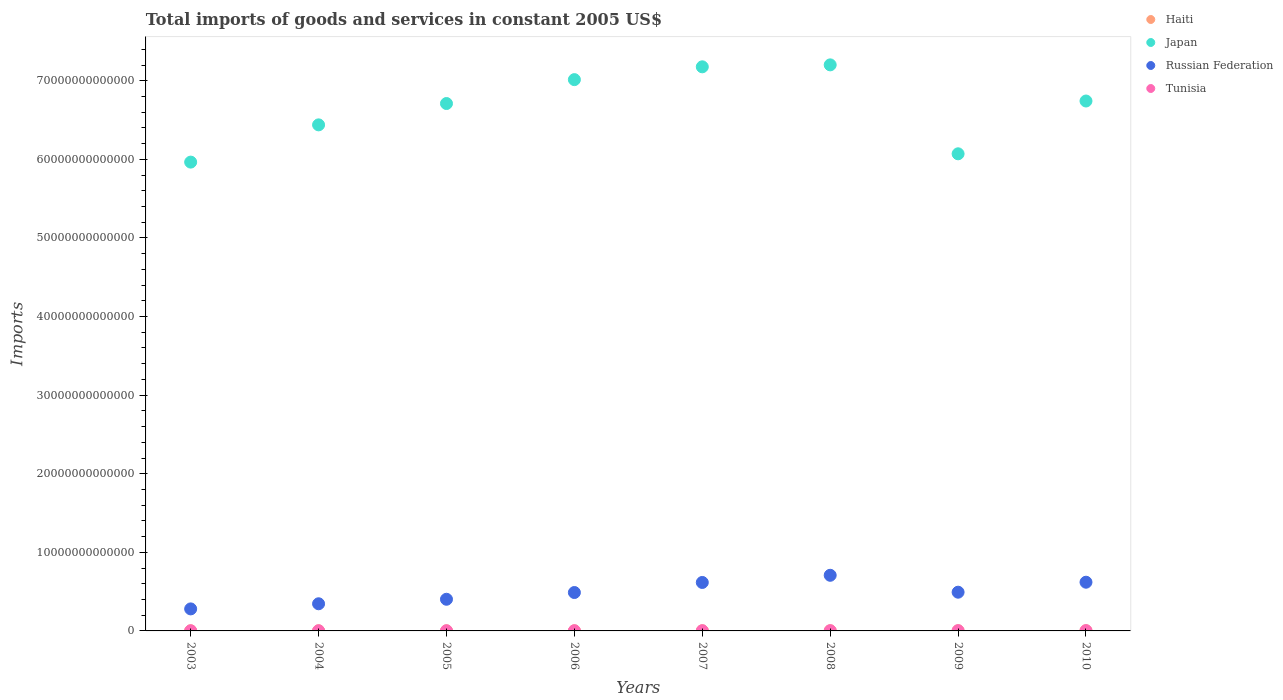How many different coloured dotlines are there?
Offer a very short reply. 4. What is the total imports of goods and services in Japan in 2008?
Offer a very short reply. 7.20e+13. Across all years, what is the maximum total imports of goods and services in Japan?
Ensure brevity in your answer.  7.20e+13. Across all years, what is the minimum total imports of goods and services in Haiti?
Offer a very short reply. 1.51e+1. What is the total total imports of goods and services in Russian Federation in the graph?
Your response must be concise. 3.95e+13. What is the difference between the total imports of goods and services in Russian Federation in 2003 and that in 2007?
Provide a succinct answer. -3.36e+12. What is the difference between the total imports of goods and services in Haiti in 2009 and the total imports of goods and services in Japan in 2008?
Offer a terse response. -7.20e+13. What is the average total imports of goods and services in Tunisia per year?
Make the answer very short. 2.48e+1. In the year 2009, what is the difference between the total imports of goods and services in Haiti and total imports of goods and services in Japan?
Give a very brief answer. -6.07e+13. What is the ratio of the total imports of goods and services in Japan in 2006 to that in 2007?
Your answer should be very brief. 0.98. Is the total imports of goods and services in Japan in 2005 less than that in 2007?
Your response must be concise. Yes. Is the difference between the total imports of goods and services in Haiti in 2003 and 2004 greater than the difference between the total imports of goods and services in Japan in 2003 and 2004?
Ensure brevity in your answer.  Yes. What is the difference between the highest and the second highest total imports of goods and services in Japan?
Make the answer very short. 2.48e+11. What is the difference between the highest and the lowest total imports of goods and services in Tunisia?
Keep it short and to the point. 1.69e+1. In how many years, is the total imports of goods and services in Russian Federation greater than the average total imports of goods and services in Russian Federation taken over all years?
Give a very brief answer. 3. Is it the case that in every year, the sum of the total imports of goods and services in Haiti and total imports of goods and services in Japan  is greater than the sum of total imports of goods and services in Russian Federation and total imports of goods and services in Tunisia?
Ensure brevity in your answer.  No. Is the total imports of goods and services in Tunisia strictly less than the total imports of goods and services in Haiti over the years?
Make the answer very short. No. How many dotlines are there?
Offer a terse response. 4. How many years are there in the graph?
Keep it short and to the point. 8. What is the difference between two consecutive major ticks on the Y-axis?
Give a very brief answer. 1.00e+13. Are the values on the major ticks of Y-axis written in scientific E-notation?
Ensure brevity in your answer.  No. Does the graph contain grids?
Provide a succinct answer. No. What is the title of the graph?
Give a very brief answer. Total imports of goods and services in constant 2005 US$. What is the label or title of the Y-axis?
Offer a very short reply. Imports. What is the Imports in Haiti in 2003?
Ensure brevity in your answer.  1.52e+1. What is the Imports of Japan in 2003?
Make the answer very short. 5.96e+13. What is the Imports in Russian Federation in 2003?
Provide a succinct answer. 2.80e+12. What is the Imports in Tunisia in 2003?
Your answer should be compact. 1.80e+1. What is the Imports of Haiti in 2004?
Offer a terse response. 1.51e+1. What is the Imports in Japan in 2004?
Your answer should be very brief. 6.44e+13. What is the Imports of Russian Federation in 2004?
Give a very brief answer. 3.45e+12. What is the Imports of Tunisia in 2004?
Offer a very short reply. 1.85e+1. What is the Imports in Haiti in 2005?
Your response must be concise. 1.61e+1. What is the Imports in Japan in 2005?
Give a very brief answer. 6.71e+13. What is the Imports of Russian Federation in 2005?
Your answer should be compact. 4.03e+12. What is the Imports in Tunisia in 2005?
Your answer should be compact. 1.84e+1. What is the Imports in Haiti in 2006?
Your response must be concise. 1.64e+1. What is the Imports of Japan in 2006?
Your answer should be compact. 7.01e+13. What is the Imports in Russian Federation in 2006?
Ensure brevity in your answer.  4.89e+12. What is the Imports of Tunisia in 2006?
Offer a terse response. 2.17e+1. What is the Imports in Haiti in 2007?
Keep it short and to the point. 1.64e+1. What is the Imports of Japan in 2007?
Keep it short and to the point. 7.18e+13. What is the Imports of Russian Federation in 2007?
Give a very brief answer. 6.17e+12. What is the Imports in Tunisia in 2007?
Offer a very short reply. 2.55e+1. What is the Imports in Haiti in 2008?
Make the answer very short. 1.73e+1. What is the Imports in Japan in 2008?
Make the answer very short. 7.20e+13. What is the Imports in Russian Federation in 2008?
Offer a very short reply. 7.08e+12. What is the Imports of Tunisia in 2008?
Offer a very short reply. 2.96e+1. What is the Imports of Haiti in 2009?
Make the answer very short. 1.83e+1. What is the Imports in Japan in 2009?
Your answer should be compact. 6.07e+13. What is the Imports in Russian Federation in 2009?
Your answer should be compact. 4.93e+12. What is the Imports in Tunisia in 2009?
Your response must be concise. 3.16e+1. What is the Imports in Haiti in 2010?
Your answer should be very brief. 2.21e+1. What is the Imports of Japan in 2010?
Your response must be concise. 6.74e+13. What is the Imports of Russian Federation in 2010?
Offer a very short reply. 6.20e+12. What is the Imports of Tunisia in 2010?
Make the answer very short. 3.49e+1. Across all years, what is the maximum Imports of Haiti?
Make the answer very short. 2.21e+1. Across all years, what is the maximum Imports of Japan?
Make the answer very short. 7.20e+13. Across all years, what is the maximum Imports of Russian Federation?
Your answer should be compact. 7.08e+12. Across all years, what is the maximum Imports in Tunisia?
Make the answer very short. 3.49e+1. Across all years, what is the minimum Imports in Haiti?
Give a very brief answer. 1.51e+1. Across all years, what is the minimum Imports in Japan?
Your answer should be very brief. 5.96e+13. Across all years, what is the minimum Imports of Russian Federation?
Your answer should be compact. 2.80e+12. Across all years, what is the minimum Imports of Tunisia?
Provide a succinct answer. 1.80e+1. What is the total Imports in Haiti in the graph?
Keep it short and to the point. 1.37e+11. What is the total Imports in Japan in the graph?
Offer a very short reply. 5.33e+14. What is the total Imports in Russian Federation in the graph?
Provide a short and direct response. 3.95e+13. What is the total Imports in Tunisia in the graph?
Ensure brevity in your answer.  1.98e+11. What is the difference between the Imports of Haiti in 2003 and that in 2004?
Keep it short and to the point. 1.62e+08. What is the difference between the Imports of Japan in 2003 and that in 2004?
Provide a short and direct response. -4.74e+12. What is the difference between the Imports in Russian Federation in 2003 and that in 2004?
Offer a very short reply. -6.53e+11. What is the difference between the Imports in Tunisia in 2003 and that in 2004?
Provide a short and direct response. -4.89e+08. What is the difference between the Imports of Haiti in 2003 and that in 2005?
Your response must be concise. -8.37e+08. What is the difference between the Imports in Japan in 2003 and that in 2005?
Keep it short and to the point. -7.45e+12. What is the difference between the Imports in Russian Federation in 2003 and that in 2005?
Your answer should be very brief. -1.23e+12. What is the difference between the Imports in Tunisia in 2003 and that in 2005?
Keep it short and to the point. -4.81e+08. What is the difference between the Imports in Haiti in 2003 and that in 2006?
Make the answer very short. -1.14e+09. What is the difference between the Imports in Japan in 2003 and that in 2006?
Your answer should be compact. -1.05e+13. What is the difference between the Imports of Russian Federation in 2003 and that in 2006?
Provide a short and direct response. -2.08e+12. What is the difference between the Imports in Tunisia in 2003 and that in 2006?
Your answer should be very brief. -3.72e+09. What is the difference between the Imports in Haiti in 2003 and that in 2007?
Give a very brief answer. -1.22e+09. What is the difference between the Imports in Japan in 2003 and that in 2007?
Offer a terse response. -1.21e+13. What is the difference between the Imports of Russian Federation in 2003 and that in 2007?
Your answer should be compact. -3.36e+12. What is the difference between the Imports in Tunisia in 2003 and that in 2007?
Ensure brevity in your answer.  -7.56e+09. What is the difference between the Imports in Haiti in 2003 and that in 2008?
Offer a terse response. -2.08e+09. What is the difference between the Imports in Japan in 2003 and that in 2008?
Offer a terse response. -1.24e+13. What is the difference between the Imports in Russian Federation in 2003 and that in 2008?
Provide a succinct answer. -4.28e+12. What is the difference between the Imports of Tunisia in 2003 and that in 2008?
Provide a succinct answer. -1.16e+1. What is the difference between the Imports of Haiti in 2003 and that in 2009?
Provide a succinct answer. -3.09e+09. What is the difference between the Imports of Japan in 2003 and that in 2009?
Ensure brevity in your answer.  -1.06e+12. What is the difference between the Imports of Russian Federation in 2003 and that in 2009?
Your answer should be very brief. -2.12e+12. What is the difference between the Imports of Tunisia in 2003 and that in 2009?
Your answer should be compact. -1.37e+1. What is the difference between the Imports in Haiti in 2003 and that in 2010?
Ensure brevity in your answer.  -6.89e+09. What is the difference between the Imports of Japan in 2003 and that in 2010?
Your answer should be very brief. -7.77e+12. What is the difference between the Imports in Russian Federation in 2003 and that in 2010?
Provide a short and direct response. -3.40e+12. What is the difference between the Imports in Tunisia in 2003 and that in 2010?
Offer a very short reply. -1.69e+1. What is the difference between the Imports in Haiti in 2004 and that in 2005?
Offer a terse response. -9.99e+08. What is the difference between the Imports of Japan in 2004 and that in 2005?
Your answer should be compact. -2.71e+12. What is the difference between the Imports in Russian Federation in 2004 and that in 2005?
Your answer should be compact. -5.73e+11. What is the difference between the Imports in Tunisia in 2004 and that in 2005?
Give a very brief answer. 8.07e+06. What is the difference between the Imports of Haiti in 2004 and that in 2006?
Provide a short and direct response. -1.30e+09. What is the difference between the Imports in Japan in 2004 and that in 2006?
Provide a succinct answer. -5.75e+12. What is the difference between the Imports of Russian Federation in 2004 and that in 2006?
Your response must be concise. -1.43e+12. What is the difference between the Imports in Tunisia in 2004 and that in 2006?
Your answer should be compact. -3.23e+09. What is the difference between the Imports of Haiti in 2004 and that in 2007?
Provide a succinct answer. -1.38e+09. What is the difference between the Imports of Japan in 2004 and that in 2007?
Give a very brief answer. -7.38e+12. What is the difference between the Imports of Russian Federation in 2004 and that in 2007?
Provide a succinct answer. -2.71e+12. What is the difference between the Imports in Tunisia in 2004 and that in 2007?
Your response must be concise. -7.07e+09. What is the difference between the Imports of Haiti in 2004 and that in 2008?
Your answer should be very brief. -2.24e+09. What is the difference between the Imports in Japan in 2004 and that in 2008?
Provide a succinct answer. -7.63e+12. What is the difference between the Imports of Russian Federation in 2004 and that in 2008?
Your answer should be very brief. -3.62e+12. What is the difference between the Imports of Tunisia in 2004 and that in 2008?
Offer a very short reply. -1.11e+1. What is the difference between the Imports of Haiti in 2004 and that in 2009?
Your answer should be compact. -3.26e+09. What is the difference between the Imports in Japan in 2004 and that in 2009?
Offer a terse response. 3.68e+12. What is the difference between the Imports in Russian Federation in 2004 and that in 2009?
Your response must be concise. -1.47e+12. What is the difference between the Imports in Tunisia in 2004 and that in 2009?
Offer a very short reply. -1.32e+1. What is the difference between the Imports of Haiti in 2004 and that in 2010?
Make the answer very short. -7.05e+09. What is the difference between the Imports in Japan in 2004 and that in 2010?
Ensure brevity in your answer.  -3.03e+12. What is the difference between the Imports in Russian Federation in 2004 and that in 2010?
Your response must be concise. -2.74e+12. What is the difference between the Imports of Tunisia in 2004 and that in 2010?
Give a very brief answer. -1.64e+1. What is the difference between the Imports in Haiti in 2005 and that in 2006?
Keep it short and to the point. -3.03e+08. What is the difference between the Imports of Japan in 2005 and that in 2006?
Provide a succinct answer. -3.04e+12. What is the difference between the Imports of Russian Federation in 2005 and that in 2006?
Offer a very short reply. -8.58e+11. What is the difference between the Imports in Tunisia in 2005 and that in 2006?
Your answer should be very brief. -3.24e+09. What is the difference between the Imports in Haiti in 2005 and that in 2007?
Your answer should be very brief. -3.78e+08. What is the difference between the Imports of Japan in 2005 and that in 2007?
Give a very brief answer. -4.67e+12. What is the difference between the Imports in Russian Federation in 2005 and that in 2007?
Make the answer very short. -2.14e+12. What is the difference between the Imports of Tunisia in 2005 and that in 2007?
Give a very brief answer. -7.08e+09. What is the difference between the Imports of Haiti in 2005 and that in 2008?
Offer a terse response. -1.24e+09. What is the difference between the Imports in Japan in 2005 and that in 2008?
Offer a very short reply. -4.92e+12. What is the difference between the Imports of Russian Federation in 2005 and that in 2008?
Your answer should be very brief. -3.05e+12. What is the difference between the Imports in Tunisia in 2005 and that in 2008?
Offer a terse response. -1.11e+1. What is the difference between the Imports in Haiti in 2005 and that in 2009?
Your response must be concise. -2.26e+09. What is the difference between the Imports of Japan in 2005 and that in 2009?
Ensure brevity in your answer.  6.40e+12. What is the difference between the Imports in Russian Federation in 2005 and that in 2009?
Provide a short and direct response. -8.99e+11. What is the difference between the Imports of Tunisia in 2005 and that in 2009?
Your answer should be compact. -1.32e+1. What is the difference between the Imports of Haiti in 2005 and that in 2010?
Provide a short and direct response. -6.06e+09. What is the difference between the Imports of Japan in 2005 and that in 2010?
Offer a very short reply. -3.20e+11. What is the difference between the Imports of Russian Federation in 2005 and that in 2010?
Give a very brief answer. -2.17e+12. What is the difference between the Imports of Tunisia in 2005 and that in 2010?
Keep it short and to the point. -1.64e+1. What is the difference between the Imports of Haiti in 2006 and that in 2007?
Give a very brief answer. -7.50e+07. What is the difference between the Imports in Japan in 2006 and that in 2007?
Provide a succinct answer. -1.63e+12. What is the difference between the Imports of Russian Federation in 2006 and that in 2007?
Your response must be concise. -1.28e+12. What is the difference between the Imports of Tunisia in 2006 and that in 2007?
Your response must be concise. -3.83e+09. What is the difference between the Imports of Haiti in 2006 and that in 2008?
Provide a succinct answer. -9.42e+08. What is the difference between the Imports of Japan in 2006 and that in 2008?
Offer a terse response. -1.88e+12. What is the difference between the Imports in Russian Federation in 2006 and that in 2008?
Your answer should be very brief. -2.19e+12. What is the difference between the Imports of Tunisia in 2006 and that in 2008?
Your answer should be very brief. -7.89e+09. What is the difference between the Imports of Haiti in 2006 and that in 2009?
Your answer should be very brief. -1.95e+09. What is the difference between the Imports of Japan in 2006 and that in 2009?
Your response must be concise. 9.44e+12. What is the difference between the Imports in Russian Federation in 2006 and that in 2009?
Ensure brevity in your answer.  -4.08e+1. What is the difference between the Imports in Tunisia in 2006 and that in 2009?
Your response must be concise. -9.94e+09. What is the difference between the Imports of Haiti in 2006 and that in 2010?
Your response must be concise. -5.75e+09. What is the difference between the Imports in Japan in 2006 and that in 2010?
Provide a succinct answer. 2.72e+12. What is the difference between the Imports in Russian Federation in 2006 and that in 2010?
Your answer should be very brief. -1.31e+12. What is the difference between the Imports in Tunisia in 2006 and that in 2010?
Provide a succinct answer. -1.32e+1. What is the difference between the Imports in Haiti in 2007 and that in 2008?
Offer a terse response. -8.67e+08. What is the difference between the Imports in Japan in 2007 and that in 2008?
Give a very brief answer. -2.48e+11. What is the difference between the Imports of Russian Federation in 2007 and that in 2008?
Give a very brief answer. -9.13e+11. What is the difference between the Imports in Tunisia in 2007 and that in 2008?
Provide a short and direct response. -4.06e+09. What is the difference between the Imports in Haiti in 2007 and that in 2009?
Provide a short and direct response. -1.88e+09. What is the difference between the Imports of Japan in 2007 and that in 2009?
Make the answer very short. 1.11e+13. What is the difference between the Imports of Russian Federation in 2007 and that in 2009?
Your response must be concise. 1.24e+12. What is the difference between the Imports in Tunisia in 2007 and that in 2009?
Provide a succinct answer. -6.11e+09. What is the difference between the Imports of Haiti in 2007 and that in 2010?
Give a very brief answer. -5.68e+09. What is the difference between the Imports in Japan in 2007 and that in 2010?
Your answer should be very brief. 4.35e+12. What is the difference between the Imports in Russian Federation in 2007 and that in 2010?
Your response must be concise. -3.18e+1. What is the difference between the Imports of Tunisia in 2007 and that in 2010?
Offer a terse response. -9.34e+09. What is the difference between the Imports in Haiti in 2008 and that in 2009?
Ensure brevity in your answer.  -1.01e+09. What is the difference between the Imports of Japan in 2008 and that in 2009?
Give a very brief answer. 1.13e+13. What is the difference between the Imports of Russian Federation in 2008 and that in 2009?
Your response must be concise. 2.15e+12. What is the difference between the Imports in Tunisia in 2008 and that in 2009?
Your response must be concise. -2.05e+09. What is the difference between the Imports of Haiti in 2008 and that in 2010?
Ensure brevity in your answer.  -4.81e+09. What is the difference between the Imports of Japan in 2008 and that in 2010?
Your answer should be compact. 4.60e+12. What is the difference between the Imports in Russian Federation in 2008 and that in 2010?
Your answer should be very brief. 8.81e+11. What is the difference between the Imports of Tunisia in 2008 and that in 2010?
Your answer should be compact. -5.28e+09. What is the difference between the Imports in Haiti in 2009 and that in 2010?
Provide a short and direct response. -3.80e+09. What is the difference between the Imports in Japan in 2009 and that in 2010?
Provide a short and direct response. -6.72e+12. What is the difference between the Imports of Russian Federation in 2009 and that in 2010?
Make the answer very short. -1.27e+12. What is the difference between the Imports in Tunisia in 2009 and that in 2010?
Offer a terse response. -3.23e+09. What is the difference between the Imports of Haiti in 2003 and the Imports of Japan in 2004?
Give a very brief answer. -6.44e+13. What is the difference between the Imports of Haiti in 2003 and the Imports of Russian Federation in 2004?
Give a very brief answer. -3.44e+12. What is the difference between the Imports of Haiti in 2003 and the Imports of Tunisia in 2004?
Provide a succinct answer. -3.23e+09. What is the difference between the Imports in Japan in 2003 and the Imports in Russian Federation in 2004?
Your response must be concise. 5.62e+13. What is the difference between the Imports of Japan in 2003 and the Imports of Tunisia in 2004?
Your answer should be compact. 5.96e+13. What is the difference between the Imports in Russian Federation in 2003 and the Imports in Tunisia in 2004?
Keep it short and to the point. 2.78e+12. What is the difference between the Imports of Haiti in 2003 and the Imports of Japan in 2005?
Your response must be concise. -6.71e+13. What is the difference between the Imports in Haiti in 2003 and the Imports in Russian Federation in 2005?
Your response must be concise. -4.01e+12. What is the difference between the Imports in Haiti in 2003 and the Imports in Tunisia in 2005?
Ensure brevity in your answer.  -3.22e+09. What is the difference between the Imports of Japan in 2003 and the Imports of Russian Federation in 2005?
Provide a succinct answer. 5.56e+13. What is the difference between the Imports of Japan in 2003 and the Imports of Tunisia in 2005?
Your answer should be very brief. 5.96e+13. What is the difference between the Imports in Russian Federation in 2003 and the Imports in Tunisia in 2005?
Provide a short and direct response. 2.78e+12. What is the difference between the Imports of Haiti in 2003 and the Imports of Japan in 2006?
Your response must be concise. -7.01e+13. What is the difference between the Imports in Haiti in 2003 and the Imports in Russian Federation in 2006?
Your answer should be compact. -4.87e+12. What is the difference between the Imports in Haiti in 2003 and the Imports in Tunisia in 2006?
Your response must be concise. -6.46e+09. What is the difference between the Imports in Japan in 2003 and the Imports in Russian Federation in 2006?
Offer a very short reply. 5.48e+13. What is the difference between the Imports of Japan in 2003 and the Imports of Tunisia in 2006?
Provide a succinct answer. 5.96e+13. What is the difference between the Imports of Russian Federation in 2003 and the Imports of Tunisia in 2006?
Provide a succinct answer. 2.78e+12. What is the difference between the Imports in Haiti in 2003 and the Imports in Japan in 2007?
Give a very brief answer. -7.18e+13. What is the difference between the Imports in Haiti in 2003 and the Imports in Russian Federation in 2007?
Your answer should be very brief. -6.15e+12. What is the difference between the Imports in Haiti in 2003 and the Imports in Tunisia in 2007?
Make the answer very short. -1.03e+1. What is the difference between the Imports in Japan in 2003 and the Imports in Russian Federation in 2007?
Your answer should be compact. 5.35e+13. What is the difference between the Imports of Japan in 2003 and the Imports of Tunisia in 2007?
Your answer should be compact. 5.96e+13. What is the difference between the Imports in Russian Federation in 2003 and the Imports in Tunisia in 2007?
Provide a succinct answer. 2.78e+12. What is the difference between the Imports of Haiti in 2003 and the Imports of Japan in 2008?
Keep it short and to the point. -7.20e+13. What is the difference between the Imports of Haiti in 2003 and the Imports of Russian Federation in 2008?
Offer a very short reply. -7.06e+12. What is the difference between the Imports of Haiti in 2003 and the Imports of Tunisia in 2008?
Provide a short and direct response. -1.43e+1. What is the difference between the Imports in Japan in 2003 and the Imports in Russian Federation in 2008?
Offer a very short reply. 5.26e+13. What is the difference between the Imports in Japan in 2003 and the Imports in Tunisia in 2008?
Provide a short and direct response. 5.96e+13. What is the difference between the Imports of Russian Federation in 2003 and the Imports of Tunisia in 2008?
Offer a very short reply. 2.77e+12. What is the difference between the Imports of Haiti in 2003 and the Imports of Japan in 2009?
Make the answer very short. -6.07e+13. What is the difference between the Imports of Haiti in 2003 and the Imports of Russian Federation in 2009?
Your response must be concise. -4.91e+12. What is the difference between the Imports of Haiti in 2003 and the Imports of Tunisia in 2009?
Keep it short and to the point. -1.64e+1. What is the difference between the Imports in Japan in 2003 and the Imports in Russian Federation in 2009?
Your response must be concise. 5.47e+13. What is the difference between the Imports of Japan in 2003 and the Imports of Tunisia in 2009?
Offer a terse response. 5.96e+13. What is the difference between the Imports of Russian Federation in 2003 and the Imports of Tunisia in 2009?
Your answer should be compact. 2.77e+12. What is the difference between the Imports in Haiti in 2003 and the Imports in Japan in 2010?
Provide a succinct answer. -6.74e+13. What is the difference between the Imports in Haiti in 2003 and the Imports in Russian Federation in 2010?
Your answer should be very brief. -6.18e+12. What is the difference between the Imports in Haiti in 2003 and the Imports in Tunisia in 2010?
Your response must be concise. -1.96e+1. What is the difference between the Imports of Japan in 2003 and the Imports of Russian Federation in 2010?
Offer a very short reply. 5.34e+13. What is the difference between the Imports in Japan in 2003 and the Imports in Tunisia in 2010?
Provide a succinct answer. 5.96e+13. What is the difference between the Imports in Russian Federation in 2003 and the Imports in Tunisia in 2010?
Offer a very short reply. 2.77e+12. What is the difference between the Imports of Haiti in 2004 and the Imports of Japan in 2005?
Your answer should be very brief. -6.71e+13. What is the difference between the Imports of Haiti in 2004 and the Imports of Russian Federation in 2005?
Make the answer very short. -4.01e+12. What is the difference between the Imports in Haiti in 2004 and the Imports in Tunisia in 2005?
Your response must be concise. -3.38e+09. What is the difference between the Imports of Japan in 2004 and the Imports of Russian Federation in 2005?
Offer a terse response. 6.04e+13. What is the difference between the Imports in Japan in 2004 and the Imports in Tunisia in 2005?
Offer a very short reply. 6.44e+13. What is the difference between the Imports in Russian Federation in 2004 and the Imports in Tunisia in 2005?
Your response must be concise. 3.44e+12. What is the difference between the Imports of Haiti in 2004 and the Imports of Japan in 2006?
Provide a short and direct response. -7.01e+13. What is the difference between the Imports of Haiti in 2004 and the Imports of Russian Federation in 2006?
Make the answer very short. -4.87e+12. What is the difference between the Imports of Haiti in 2004 and the Imports of Tunisia in 2006?
Your response must be concise. -6.62e+09. What is the difference between the Imports in Japan in 2004 and the Imports in Russian Federation in 2006?
Ensure brevity in your answer.  5.95e+13. What is the difference between the Imports of Japan in 2004 and the Imports of Tunisia in 2006?
Make the answer very short. 6.44e+13. What is the difference between the Imports of Russian Federation in 2004 and the Imports of Tunisia in 2006?
Offer a very short reply. 3.43e+12. What is the difference between the Imports in Haiti in 2004 and the Imports in Japan in 2007?
Provide a short and direct response. -7.18e+13. What is the difference between the Imports of Haiti in 2004 and the Imports of Russian Federation in 2007?
Give a very brief answer. -6.15e+12. What is the difference between the Imports of Haiti in 2004 and the Imports of Tunisia in 2007?
Your answer should be very brief. -1.05e+1. What is the difference between the Imports in Japan in 2004 and the Imports in Russian Federation in 2007?
Make the answer very short. 5.82e+13. What is the difference between the Imports in Japan in 2004 and the Imports in Tunisia in 2007?
Offer a very short reply. 6.44e+13. What is the difference between the Imports in Russian Federation in 2004 and the Imports in Tunisia in 2007?
Your answer should be compact. 3.43e+12. What is the difference between the Imports in Haiti in 2004 and the Imports in Japan in 2008?
Your answer should be very brief. -7.20e+13. What is the difference between the Imports of Haiti in 2004 and the Imports of Russian Federation in 2008?
Give a very brief answer. -7.06e+12. What is the difference between the Imports in Haiti in 2004 and the Imports in Tunisia in 2008?
Make the answer very short. -1.45e+1. What is the difference between the Imports in Japan in 2004 and the Imports in Russian Federation in 2008?
Provide a short and direct response. 5.73e+13. What is the difference between the Imports of Japan in 2004 and the Imports of Tunisia in 2008?
Your answer should be very brief. 6.44e+13. What is the difference between the Imports in Russian Federation in 2004 and the Imports in Tunisia in 2008?
Your answer should be compact. 3.42e+12. What is the difference between the Imports of Haiti in 2004 and the Imports of Japan in 2009?
Your answer should be very brief. -6.07e+13. What is the difference between the Imports in Haiti in 2004 and the Imports in Russian Federation in 2009?
Offer a very short reply. -4.91e+12. What is the difference between the Imports of Haiti in 2004 and the Imports of Tunisia in 2009?
Your response must be concise. -1.66e+1. What is the difference between the Imports in Japan in 2004 and the Imports in Russian Federation in 2009?
Offer a very short reply. 5.95e+13. What is the difference between the Imports in Japan in 2004 and the Imports in Tunisia in 2009?
Keep it short and to the point. 6.44e+13. What is the difference between the Imports in Russian Federation in 2004 and the Imports in Tunisia in 2009?
Provide a short and direct response. 3.42e+12. What is the difference between the Imports in Haiti in 2004 and the Imports in Japan in 2010?
Offer a very short reply. -6.74e+13. What is the difference between the Imports of Haiti in 2004 and the Imports of Russian Federation in 2010?
Keep it short and to the point. -6.18e+12. What is the difference between the Imports of Haiti in 2004 and the Imports of Tunisia in 2010?
Ensure brevity in your answer.  -1.98e+1. What is the difference between the Imports of Japan in 2004 and the Imports of Russian Federation in 2010?
Ensure brevity in your answer.  5.82e+13. What is the difference between the Imports in Japan in 2004 and the Imports in Tunisia in 2010?
Ensure brevity in your answer.  6.44e+13. What is the difference between the Imports in Russian Federation in 2004 and the Imports in Tunisia in 2010?
Your answer should be very brief. 3.42e+12. What is the difference between the Imports of Haiti in 2005 and the Imports of Japan in 2006?
Give a very brief answer. -7.01e+13. What is the difference between the Imports in Haiti in 2005 and the Imports in Russian Federation in 2006?
Keep it short and to the point. -4.87e+12. What is the difference between the Imports in Haiti in 2005 and the Imports in Tunisia in 2006?
Give a very brief answer. -5.62e+09. What is the difference between the Imports in Japan in 2005 and the Imports in Russian Federation in 2006?
Your answer should be very brief. 6.22e+13. What is the difference between the Imports in Japan in 2005 and the Imports in Tunisia in 2006?
Offer a terse response. 6.71e+13. What is the difference between the Imports in Russian Federation in 2005 and the Imports in Tunisia in 2006?
Ensure brevity in your answer.  4.01e+12. What is the difference between the Imports of Haiti in 2005 and the Imports of Japan in 2007?
Ensure brevity in your answer.  -7.18e+13. What is the difference between the Imports in Haiti in 2005 and the Imports in Russian Federation in 2007?
Your answer should be very brief. -6.15e+12. What is the difference between the Imports in Haiti in 2005 and the Imports in Tunisia in 2007?
Your response must be concise. -9.46e+09. What is the difference between the Imports in Japan in 2005 and the Imports in Russian Federation in 2007?
Provide a succinct answer. 6.09e+13. What is the difference between the Imports of Japan in 2005 and the Imports of Tunisia in 2007?
Your answer should be very brief. 6.71e+13. What is the difference between the Imports of Russian Federation in 2005 and the Imports of Tunisia in 2007?
Your answer should be very brief. 4.00e+12. What is the difference between the Imports in Haiti in 2005 and the Imports in Japan in 2008?
Give a very brief answer. -7.20e+13. What is the difference between the Imports in Haiti in 2005 and the Imports in Russian Federation in 2008?
Keep it short and to the point. -7.06e+12. What is the difference between the Imports in Haiti in 2005 and the Imports in Tunisia in 2008?
Offer a very short reply. -1.35e+1. What is the difference between the Imports in Japan in 2005 and the Imports in Russian Federation in 2008?
Your answer should be compact. 6.00e+13. What is the difference between the Imports of Japan in 2005 and the Imports of Tunisia in 2008?
Your answer should be compact. 6.71e+13. What is the difference between the Imports of Russian Federation in 2005 and the Imports of Tunisia in 2008?
Your answer should be very brief. 4.00e+12. What is the difference between the Imports in Haiti in 2005 and the Imports in Japan in 2009?
Keep it short and to the point. -6.07e+13. What is the difference between the Imports of Haiti in 2005 and the Imports of Russian Federation in 2009?
Make the answer very short. -4.91e+12. What is the difference between the Imports of Haiti in 2005 and the Imports of Tunisia in 2009?
Give a very brief answer. -1.56e+1. What is the difference between the Imports in Japan in 2005 and the Imports in Russian Federation in 2009?
Offer a very short reply. 6.22e+13. What is the difference between the Imports in Japan in 2005 and the Imports in Tunisia in 2009?
Ensure brevity in your answer.  6.71e+13. What is the difference between the Imports of Russian Federation in 2005 and the Imports of Tunisia in 2009?
Provide a short and direct response. 4.00e+12. What is the difference between the Imports in Haiti in 2005 and the Imports in Japan in 2010?
Your answer should be very brief. -6.74e+13. What is the difference between the Imports in Haiti in 2005 and the Imports in Russian Federation in 2010?
Your answer should be compact. -6.18e+12. What is the difference between the Imports in Haiti in 2005 and the Imports in Tunisia in 2010?
Offer a very short reply. -1.88e+1. What is the difference between the Imports of Japan in 2005 and the Imports of Russian Federation in 2010?
Provide a succinct answer. 6.09e+13. What is the difference between the Imports in Japan in 2005 and the Imports in Tunisia in 2010?
Offer a terse response. 6.71e+13. What is the difference between the Imports of Russian Federation in 2005 and the Imports of Tunisia in 2010?
Ensure brevity in your answer.  3.99e+12. What is the difference between the Imports in Haiti in 2006 and the Imports in Japan in 2007?
Give a very brief answer. -7.18e+13. What is the difference between the Imports of Haiti in 2006 and the Imports of Russian Federation in 2007?
Your answer should be very brief. -6.15e+12. What is the difference between the Imports in Haiti in 2006 and the Imports in Tunisia in 2007?
Keep it short and to the point. -9.15e+09. What is the difference between the Imports of Japan in 2006 and the Imports of Russian Federation in 2007?
Ensure brevity in your answer.  6.40e+13. What is the difference between the Imports of Japan in 2006 and the Imports of Tunisia in 2007?
Provide a short and direct response. 7.01e+13. What is the difference between the Imports of Russian Federation in 2006 and the Imports of Tunisia in 2007?
Ensure brevity in your answer.  4.86e+12. What is the difference between the Imports of Haiti in 2006 and the Imports of Japan in 2008?
Your answer should be very brief. -7.20e+13. What is the difference between the Imports of Haiti in 2006 and the Imports of Russian Federation in 2008?
Keep it short and to the point. -7.06e+12. What is the difference between the Imports in Haiti in 2006 and the Imports in Tunisia in 2008?
Offer a terse response. -1.32e+1. What is the difference between the Imports of Japan in 2006 and the Imports of Russian Federation in 2008?
Your answer should be compact. 6.31e+13. What is the difference between the Imports of Japan in 2006 and the Imports of Tunisia in 2008?
Your response must be concise. 7.01e+13. What is the difference between the Imports in Russian Federation in 2006 and the Imports in Tunisia in 2008?
Your response must be concise. 4.86e+12. What is the difference between the Imports of Haiti in 2006 and the Imports of Japan in 2009?
Offer a terse response. -6.07e+13. What is the difference between the Imports of Haiti in 2006 and the Imports of Russian Federation in 2009?
Ensure brevity in your answer.  -4.91e+12. What is the difference between the Imports of Haiti in 2006 and the Imports of Tunisia in 2009?
Your answer should be compact. -1.53e+1. What is the difference between the Imports in Japan in 2006 and the Imports in Russian Federation in 2009?
Your answer should be compact. 6.52e+13. What is the difference between the Imports of Japan in 2006 and the Imports of Tunisia in 2009?
Offer a terse response. 7.01e+13. What is the difference between the Imports of Russian Federation in 2006 and the Imports of Tunisia in 2009?
Give a very brief answer. 4.85e+12. What is the difference between the Imports of Haiti in 2006 and the Imports of Japan in 2010?
Make the answer very short. -6.74e+13. What is the difference between the Imports of Haiti in 2006 and the Imports of Russian Federation in 2010?
Provide a short and direct response. -6.18e+12. What is the difference between the Imports in Haiti in 2006 and the Imports in Tunisia in 2010?
Ensure brevity in your answer.  -1.85e+1. What is the difference between the Imports of Japan in 2006 and the Imports of Russian Federation in 2010?
Give a very brief answer. 6.39e+13. What is the difference between the Imports in Japan in 2006 and the Imports in Tunisia in 2010?
Ensure brevity in your answer.  7.01e+13. What is the difference between the Imports of Russian Federation in 2006 and the Imports of Tunisia in 2010?
Keep it short and to the point. 4.85e+12. What is the difference between the Imports of Haiti in 2007 and the Imports of Japan in 2008?
Give a very brief answer. -7.20e+13. What is the difference between the Imports in Haiti in 2007 and the Imports in Russian Federation in 2008?
Offer a terse response. -7.06e+12. What is the difference between the Imports in Haiti in 2007 and the Imports in Tunisia in 2008?
Offer a terse response. -1.31e+1. What is the difference between the Imports of Japan in 2007 and the Imports of Russian Federation in 2008?
Offer a terse response. 6.47e+13. What is the difference between the Imports in Japan in 2007 and the Imports in Tunisia in 2008?
Provide a short and direct response. 7.17e+13. What is the difference between the Imports in Russian Federation in 2007 and the Imports in Tunisia in 2008?
Provide a succinct answer. 6.14e+12. What is the difference between the Imports of Haiti in 2007 and the Imports of Japan in 2009?
Provide a short and direct response. -6.07e+13. What is the difference between the Imports of Haiti in 2007 and the Imports of Russian Federation in 2009?
Give a very brief answer. -4.91e+12. What is the difference between the Imports of Haiti in 2007 and the Imports of Tunisia in 2009?
Give a very brief answer. -1.52e+1. What is the difference between the Imports in Japan in 2007 and the Imports in Russian Federation in 2009?
Make the answer very short. 6.68e+13. What is the difference between the Imports of Japan in 2007 and the Imports of Tunisia in 2009?
Keep it short and to the point. 7.17e+13. What is the difference between the Imports of Russian Federation in 2007 and the Imports of Tunisia in 2009?
Offer a very short reply. 6.13e+12. What is the difference between the Imports of Haiti in 2007 and the Imports of Japan in 2010?
Your response must be concise. -6.74e+13. What is the difference between the Imports in Haiti in 2007 and the Imports in Russian Federation in 2010?
Your response must be concise. -6.18e+12. What is the difference between the Imports of Haiti in 2007 and the Imports of Tunisia in 2010?
Provide a short and direct response. -1.84e+1. What is the difference between the Imports of Japan in 2007 and the Imports of Russian Federation in 2010?
Keep it short and to the point. 6.56e+13. What is the difference between the Imports in Japan in 2007 and the Imports in Tunisia in 2010?
Your answer should be very brief. 7.17e+13. What is the difference between the Imports of Russian Federation in 2007 and the Imports of Tunisia in 2010?
Offer a very short reply. 6.13e+12. What is the difference between the Imports in Haiti in 2008 and the Imports in Japan in 2009?
Your response must be concise. -6.07e+13. What is the difference between the Imports of Haiti in 2008 and the Imports of Russian Federation in 2009?
Offer a terse response. -4.91e+12. What is the difference between the Imports of Haiti in 2008 and the Imports of Tunisia in 2009?
Provide a short and direct response. -1.43e+1. What is the difference between the Imports of Japan in 2008 and the Imports of Russian Federation in 2009?
Offer a terse response. 6.71e+13. What is the difference between the Imports of Japan in 2008 and the Imports of Tunisia in 2009?
Keep it short and to the point. 7.20e+13. What is the difference between the Imports in Russian Federation in 2008 and the Imports in Tunisia in 2009?
Keep it short and to the point. 7.05e+12. What is the difference between the Imports in Haiti in 2008 and the Imports in Japan in 2010?
Offer a very short reply. -6.74e+13. What is the difference between the Imports of Haiti in 2008 and the Imports of Russian Federation in 2010?
Provide a succinct answer. -6.18e+12. What is the difference between the Imports of Haiti in 2008 and the Imports of Tunisia in 2010?
Give a very brief answer. -1.75e+1. What is the difference between the Imports of Japan in 2008 and the Imports of Russian Federation in 2010?
Offer a terse response. 6.58e+13. What is the difference between the Imports in Japan in 2008 and the Imports in Tunisia in 2010?
Give a very brief answer. 7.20e+13. What is the difference between the Imports of Russian Federation in 2008 and the Imports of Tunisia in 2010?
Ensure brevity in your answer.  7.04e+12. What is the difference between the Imports of Haiti in 2009 and the Imports of Japan in 2010?
Your response must be concise. -6.74e+13. What is the difference between the Imports in Haiti in 2009 and the Imports in Russian Federation in 2010?
Your response must be concise. -6.18e+12. What is the difference between the Imports in Haiti in 2009 and the Imports in Tunisia in 2010?
Provide a short and direct response. -1.65e+1. What is the difference between the Imports of Japan in 2009 and the Imports of Russian Federation in 2010?
Your response must be concise. 5.45e+13. What is the difference between the Imports in Japan in 2009 and the Imports in Tunisia in 2010?
Make the answer very short. 6.07e+13. What is the difference between the Imports in Russian Federation in 2009 and the Imports in Tunisia in 2010?
Ensure brevity in your answer.  4.89e+12. What is the average Imports of Haiti per year?
Your answer should be very brief. 1.71e+1. What is the average Imports of Japan per year?
Keep it short and to the point. 6.66e+13. What is the average Imports in Russian Federation per year?
Your answer should be compact. 4.94e+12. What is the average Imports of Tunisia per year?
Your response must be concise. 2.48e+1. In the year 2003, what is the difference between the Imports in Haiti and Imports in Japan?
Your answer should be very brief. -5.96e+13. In the year 2003, what is the difference between the Imports of Haiti and Imports of Russian Federation?
Offer a terse response. -2.79e+12. In the year 2003, what is the difference between the Imports in Haiti and Imports in Tunisia?
Make the answer very short. -2.74e+09. In the year 2003, what is the difference between the Imports of Japan and Imports of Russian Federation?
Keep it short and to the point. 5.68e+13. In the year 2003, what is the difference between the Imports in Japan and Imports in Tunisia?
Keep it short and to the point. 5.96e+13. In the year 2003, what is the difference between the Imports in Russian Federation and Imports in Tunisia?
Your answer should be very brief. 2.78e+12. In the year 2004, what is the difference between the Imports of Haiti and Imports of Japan?
Provide a succinct answer. -6.44e+13. In the year 2004, what is the difference between the Imports of Haiti and Imports of Russian Federation?
Provide a short and direct response. -3.44e+12. In the year 2004, what is the difference between the Imports of Haiti and Imports of Tunisia?
Make the answer very short. -3.39e+09. In the year 2004, what is the difference between the Imports of Japan and Imports of Russian Federation?
Provide a succinct answer. 6.09e+13. In the year 2004, what is the difference between the Imports in Japan and Imports in Tunisia?
Keep it short and to the point. 6.44e+13. In the year 2004, what is the difference between the Imports in Russian Federation and Imports in Tunisia?
Your answer should be compact. 3.44e+12. In the year 2005, what is the difference between the Imports of Haiti and Imports of Japan?
Ensure brevity in your answer.  -6.71e+13. In the year 2005, what is the difference between the Imports in Haiti and Imports in Russian Federation?
Your answer should be very brief. -4.01e+12. In the year 2005, what is the difference between the Imports in Haiti and Imports in Tunisia?
Provide a succinct answer. -2.38e+09. In the year 2005, what is the difference between the Imports of Japan and Imports of Russian Federation?
Make the answer very short. 6.31e+13. In the year 2005, what is the difference between the Imports of Japan and Imports of Tunisia?
Your answer should be compact. 6.71e+13. In the year 2005, what is the difference between the Imports of Russian Federation and Imports of Tunisia?
Keep it short and to the point. 4.01e+12. In the year 2006, what is the difference between the Imports of Haiti and Imports of Japan?
Give a very brief answer. -7.01e+13. In the year 2006, what is the difference between the Imports of Haiti and Imports of Russian Federation?
Give a very brief answer. -4.87e+12. In the year 2006, what is the difference between the Imports in Haiti and Imports in Tunisia?
Provide a short and direct response. -5.32e+09. In the year 2006, what is the difference between the Imports in Japan and Imports in Russian Federation?
Make the answer very short. 6.53e+13. In the year 2006, what is the difference between the Imports in Japan and Imports in Tunisia?
Your response must be concise. 7.01e+13. In the year 2006, what is the difference between the Imports in Russian Federation and Imports in Tunisia?
Keep it short and to the point. 4.86e+12. In the year 2007, what is the difference between the Imports in Haiti and Imports in Japan?
Your response must be concise. -7.18e+13. In the year 2007, what is the difference between the Imports of Haiti and Imports of Russian Federation?
Ensure brevity in your answer.  -6.15e+12. In the year 2007, what is the difference between the Imports of Haiti and Imports of Tunisia?
Offer a very short reply. -9.08e+09. In the year 2007, what is the difference between the Imports of Japan and Imports of Russian Federation?
Offer a very short reply. 6.56e+13. In the year 2007, what is the difference between the Imports of Japan and Imports of Tunisia?
Ensure brevity in your answer.  7.17e+13. In the year 2007, what is the difference between the Imports of Russian Federation and Imports of Tunisia?
Your response must be concise. 6.14e+12. In the year 2008, what is the difference between the Imports of Haiti and Imports of Japan?
Provide a succinct answer. -7.20e+13. In the year 2008, what is the difference between the Imports in Haiti and Imports in Russian Federation?
Provide a short and direct response. -7.06e+12. In the year 2008, what is the difference between the Imports of Haiti and Imports of Tunisia?
Make the answer very short. -1.23e+1. In the year 2008, what is the difference between the Imports of Japan and Imports of Russian Federation?
Give a very brief answer. 6.49e+13. In the year 2008, what is the difference between the Imports of Japan and Imports of Tunisia?
Give a very brief answer. 7.20e+13. In the year 2008, what is the difference between the Imports of Russian Federation and Imports of Tunisia?
Keep it short and to the point. 7.05e+12. In the year 2009, what is the difference between the Imports of Haiti and Imports of Japan?
Ensure brevity in your answer.  -6.07e+13. In the year 2009, what is the difference between the Imports in Haiti and Imports in Russian Federation?
Provide a short and direct response. -4.91e+12. In the year 2009, what is the difference between the Imports in Haiti and Imports in Tunisia?
Provide a succinct answer. -1.33e+1. In the year 2009, what is the difference between the Imports in Japan and Imports in Russian Federation?
Offer a terse response. 5.58e+13. In the year 2009, what is the difference between the Imports in Japan and Imports in Tunisia?
Keep it short and to the point. 6.07e+13. In the year 2009, what is the difference between the Imports in Russian Federation and Imports in Tunisia?
Offer a terse response. 4.89e+12. In the year 2010, what is the difference between the Imports in Haiti and Imports in Japan?
Offer a very short reply. -6.74e+13. In the year 2010, what is the difference between the Imports of Haiti and Imports of Russian Federation?
Your answer should be compact. -6.18e+12. In the year 2010, what is the difference between the Imports of Haiti and Imports of Tunisia?
Offer a very short reply. -1.27e+1. In the year 2010, what is the difference between the Imports of Japan and Imports of Russian Federation?
Make the answer very short. 6.12e+13. In the year 2010, what is the difference between the Imports in Japan and Imports in Tunisia?
Offer a terse response. 6.74e+13. In the year 2010, what is the difference between the Imports of Russian Federation and Imports of Tunisia?
Make the answer very short. 6.16e+12. What is the ratio of the Imports in Haiti in 2003 to that in 2004?
Keep it short and to the point. 1.01. What is the ratio of the Imports of Japan in 2003 to that in 2004?
Offer a terse response. 0.93. What is the ratio of the Imports of Russian Federation in 2003 to that in 2004?
Offer a very short reply. 0.81. What is the ratio of the Imports of Tunisia in 2003 to that in 2004?
Provide a short and direct response. 0.97. What is the ratio of the Imports in Haiti in 2003 to that in 2005?
Your answer should be very brief. 0.95. What is the ratio of the Imports of Russian Federation in 2003 to that in 2005?
Ensure brevity in your answer.  0.7. What is the ratio of the Imports in Tunisia in 2003 to that in 2005?
Offer a terse response. 0.97. What is the ratio of the Imports of Haiti in 2003 to that in 2006?
Your answer should be compact. 0.93. What is the ratio of the Imports of Japan in 2003 to that in 2006?
Provide a succinct answer. 0.85. What is the ratio of the Imports of Russian Federation in 2003 to that in 2006?
Make the answer very short. 0.57. What is the ratio of the Imports in Tunisia in 2003 to that in 2006?
Offer a very short reply. 0.83. What is the ratio of the Imports of Haiti in 2003 to that in 2007?
Provide a succinct answer. 0.93. What is the ratio of the Imports of Japan in 2003 to that in 2007?
Your response must be concise. 0.83. What is the ratio of the Imports in Russian Federation in 2003 to that in 2007?
Your answer should be compact. 0.45. What is the ratio of the Imports in Tunisia in 2003 to that in 2007?
Keep it short and to the point. 0.7. What is the ratio of the Imports in Haiti in 2003 to that in 2008?
Give a very brief answer. 0.88. What is the ratio of the Imports of Japan in 2003 to that in 2008?
Give a very brief answer. 0.83. What is the ratio of the Imports in Russian Federation in 2003 to that in 2008?
Offer a terse response. 0.4. What is the ratio of the Imports of Tunisia in 2003 to that in 2008?
Provide a succinct answer. 0.61. What is the ratio of the Imports of Haiti in 2003 to that in 2009?
Provide a short and direct response. 0.83. What is the ratio of the Imports in Japan in 2003 to that in 2009?
Give a very brief answer. 0.98. What is the ratio of the Imports in Russian Federation in 2003 to that in 2009?
Your response must be concise. 0.57. What is the ratio of the Imports of Tunisia in 2003 to that in 2009?
Your answer should be compact. 0.57. What is the ratio of the Imports of Haiti in 2003 to that in 2010?
Make the answer very short. 0.69. What is the ratio of the Imports in Japan in 2003 to that in 2010?
Your response must be concise. 0.88. What is the ratio of the Imports of Russian Federation in 2003 to that in 2010?
Offer a very short reply. 0.45. What is the ratio of the Imports in Tunisia in 2003 to that in 2010?
Your answer should be compact. 0.52. What is the ratio of the Imports in Haiti in 2004 to that in 2005?
Provide a succinct answer. 0.94. What is the ratio of the Imports of Japan in 2004 to that in 2005?
Offer a terse response. 0.96. What is the ratio of the Imports in Russian Federation in 2004 to that in 2005?
Ensure brevity in your answer.  0.86. What is the ratio of the Imports in Tunisia in 2004 to that in 2005?
Your response must be concise. 1. What is the ratio of the Imports in Haiti in 2004 to that in 2006?
Offer a terse response. 0.92. What is the ratio of the Imports in Japan in 2004 to that in 2006?
Offer a very short reply. 0.92. What is the ratio of the Imports in Russian Federation in 2004 to that in 2006?
Give a very brief answer. 0.71. What is the ratio of the Imports in Tunisia in 2004 to that in 2006?
Your answer should be compact. 0.85. What is the ratio of the Imports of Haiti in 2004 to that in 2007?
Ensure brevity in your answer.  0.92. What is the ratio of the Imports of Japan in 2004 to that in 2007?
Offer a very short reply. 0.9. What is the ratio of the Imports in Russian Federation in 2004 to that in 2007?
Your answer should be compact. 0.56. What is the ratio of the Imports of Tunisia in 2004 to that in 2007?
Ensure brevity in your answer.  0.72. What is the ratio of the Imports of Haiti in 2004 to that in 2008?
Give a very brief answer. 0.87. What is the ratio of the Imports of Japan in 2004 to that in 2008?
Your response must be concise. 0.89. What is the ratio of the Imports in Russian Federation in 2004 to that in 2008?
Your response must be concise. 0.49. What is the ratio of the Imports in Tunisia in 2004 to that in 2008?
Offer a terse response. 0.62. What is the ratio of the Imports in Haiti in 2004 to that in 2009?
Your response must be concise. 0.82. What is the ratio of the Imports of Japan in 2004 to that in 2009?
Provide a short and direct response. 1.06. What is the ratio of the Imports of Russian Federation in 2004 to that in 2009?
Keep it short and to the point. 0.7. What is the ratio of the Imports of Tunisia in 2004 to that in 2009?
Ensure brevity in your answer.  0.58. What is the ratio of the Imports of Haiti in 2004 to that in 2010?
Provide a succinct answer. 0.68. What is the ratio of the Imports in Japan in 2004 to that in 2010?
Your response must be concise. 0.95. What is the ratio of the Imports in Russian Federation in 2004 to that in 2010?
Offer a very short reply. 0.56. What is the ratio of the Imports of Tunisia in 2004 to that in 2010?
Ensure brevity in your answer.  0.53. What is the ratio of the Imports of Haiti in 2005 to that in 2006?
Offer a terse response. 0.98. What is the ratio of the Imports in Japan in 2005 to that in 2006?
Offer a very short reply. 0.96. What is the ratio of the Imports in Russian Federation in 2005 to that in 2006?
Keep it short and to the point. 0.82. What is the ratio of the Imports in Tunisia in 2005 to that in 2006?
Offer a very short reply. 0.85. What is the ratio of the Imports of Haiti in 2005 to that in 2007?
Your answer should be compact. 0.98. What is the ratio of the Imports in Japan in 2005 to that in 2007?
Offer a terse response. 0.93. What is the ratio of the Imports in Russian Federation in 2005 to that in 2007?
Give a very brief answer. 0.65. What is the ratio of the Imports in Tunisia in 2005 to that in 2007?
Your answer should be very brief. 0.72. What is the ratio of the Imports in Haiti in 2005 to that in 2008?
Offer a terse response. 0.93. What is the ratio of the Imports of Japan in 2005 to that in 2008?
Your answer should be very brief. 0.93. What is the ratio of the Imports of Russian Federation in 2005 to that in 2008?
Your answer should be very brief. 0.57. What is the ratio of the Imports in Tunisia in 2005 to that in 2008?
Keep it short and to the point. 0.62. What is the ratio of the Imports in Haiti in 2005 to that in 2009?
Offer a very short reply. 0.88. What is the ratio of the Imports of Japan in 2005 to that in 2009?
Give a very brief answer. 1.11. What is the ratio of the Imports in Russian Federation in 2005 to that in 2009?
Offer a terse response. 0.82. What is the ratio of the Imports in Tunisia in 2005 to that in 2009?
Keep it short and to the point. 0.58. What is the ratio of the Imports in Haiti in 2005 to that in 2010?
Provide a succinct answer. 0.73. What is the ratio of the Imports of Japan in 2005 to that in 2010?
Provide a succinct answer. 1. What is the ratio of the Imports in Russian Federation in 2005 to that in 2010?
Your response must be concise. 0.65. What is the ratio of the Imports of Tunisia in 2005 to that in 2010?
Offer a very short reply. 0.53. What is the ratio of the Imports in Japan in 2006 to that in 2007?
Your response must be concise. 0.98. What is the ratio of the Imports in Russian Federation in 2006 to that in 2007?
Make the answer very short. 0.79. What is the ratio of the Imports in Tunisia in 2006 to that in 2007?
Ensure brevity in your answer.  0.85. What is the ratio of the Imports in Haiti in 2006 to that in 2008?
Your answer should be very brief. 0.95. What is the ratio of the Imports in Japan in 2006 to that in 2008?
Provide a succinct answer. 0.97. What is the ratio of the Imports of Russian Federation in 2006 to that in 2008?
Offer a terse response. 0.69. What is the ratio of the Imports of Tunisia in 2006 to that in 2008?
Ensure brevity in your answer.  0.73. What is the ratio of the Imports in Haiti in 2006 to that in 2009?
Your answer should be compact. 0.89. What is the ratio of the Imports in Japan in 2006 to that in 2009?
Your answer should be compact. 1.16. What is the ratio of the Imports in Tunisia in 2006 to that in 2009?
Give a very brief answer. 0.69. What is the ratio of the Imports in Haiti in 2006 to that in 2010?
Make the answer very short. 0.74. What is the ratio of the Imports in Japan in 2006 to that in 2010?
Provide a short and direct response. 1.04. What is the ratio of the Imports in Russian Federation in 2006 to that in 2010?
Make the answer very short. 0.79. What is the ratio of the Imports in Tunisia in 2006 to that in 2010?
Your answer should be compact. 0.62. What is the ratio of the Imports of Haiti in 2007 to that in 2008?
Your answer should be compact. 0.95. What is the ratio of the Imports of Russian Federation in 2007 to that in 2008?
Provide a short and direct response. 0.87. What is the ratio of the Imports in Tunisia in 2007 to that in 2008?
Make the answer very short. 0.86. What is the ratio of the Imports of Haiti in 2007 to that in 2009?
Make the answer very short. 0.9. What is the ratio of the Imports in Japan in 2007 to that in 2009?
Provide a short and direct response. 1.18. What is the ratio of the Imports of Russian Federation in 2007 to that in 2009?
Provide a succinct answer. 1.25. What is the ratio of the Imports of Tunisia in 2007 to that in 2009?
Provide a short and direct response. 0.81. What is the ratio of the Imports in Haiti in 2007 to that in 2010?
Ensure brevity in your answer.  0.74. What is the ratio of the Imports of Japan in 2007 to that in 2010?
Offer a terse response. 1.06. What is the ratio of the Imports in Tunisia in 2007 to that in 2010?
Your answer should be compact. 0.73. What is the ratio of the Imports of Haiti in 2008 to that in 2009?
Your response must be concise. 0.94. What is the ratio of the Imports in Japan in 2008 to that in 2009?
Ensure brevity in your answer.  1.19. What is the ratio of the Imports in Russian Federation in 2008 to that in 2009?
Give a very brief answer. 1.44. What is the ratio of the Imports in Tunisia in 2008 to that in 2009?
Give a very brief answer. 0.94. What is the ratio of the Imports in Haiti in 2008 to that in 2010?
Ensure brevity in your answer.  0.78. What is the ratio of the Imports in Japan in 2008 to that in 2010?
Provide a succinct answer. 1.07. What is the ratio of the Imports in Russian Federation in 2008 to that in 2010?
Ensure brevity in your answer.  1.14. What is the ratio of the Imports in Tunisia in 2008 to that in 2010?
Offer a very short reply. 0.85. What is the ratio of the Imports of Haiti in 2009 to that in 2010?
Offer a terse response. 0.83. What is the ratio of the Imports in Japan in 2009 to that in 2010?
Give a very brief answer. 0.9. What is the ratio of the Imports of Russian Federation in 2009 to that in 2010?
Ensure brevity in your answer.  0.79. What is the ratio of the Imports in Tunisia in 2009 to that in 2010?
Give a very brief answer. 0.91. What is the difference between the highest and the second highest Imports in Haiti?
Offer a very short reply. 3.80e+09. What is the difference between the highest and the second highest Imports in Japan?
Provide a succinct answer. 2.48e+11. What is the difference between the highest and the second highest Imports in Russian Federation?
Make the answer very short. 8.81e+11. What is the difference between the highest and the second highest Imports of Tunisia?
Give a very brief answer. 3.23e+09. What is the difference between the highest and the lowest Imports in Haiti?
Make the answer very short. 7.05e+09. What is the difference between the highest and the lowest Imports of Japan?
Your answer should be very brief. 1.24e+13. What is the difference between the highest and the lowest Imports of Russian Federation?
Ensure brevity in your answer.  4.28e+12. What is the difference between the highest and the lowest Imports of Tunisia?
Your answer should be very brief. 1.69e+1. 